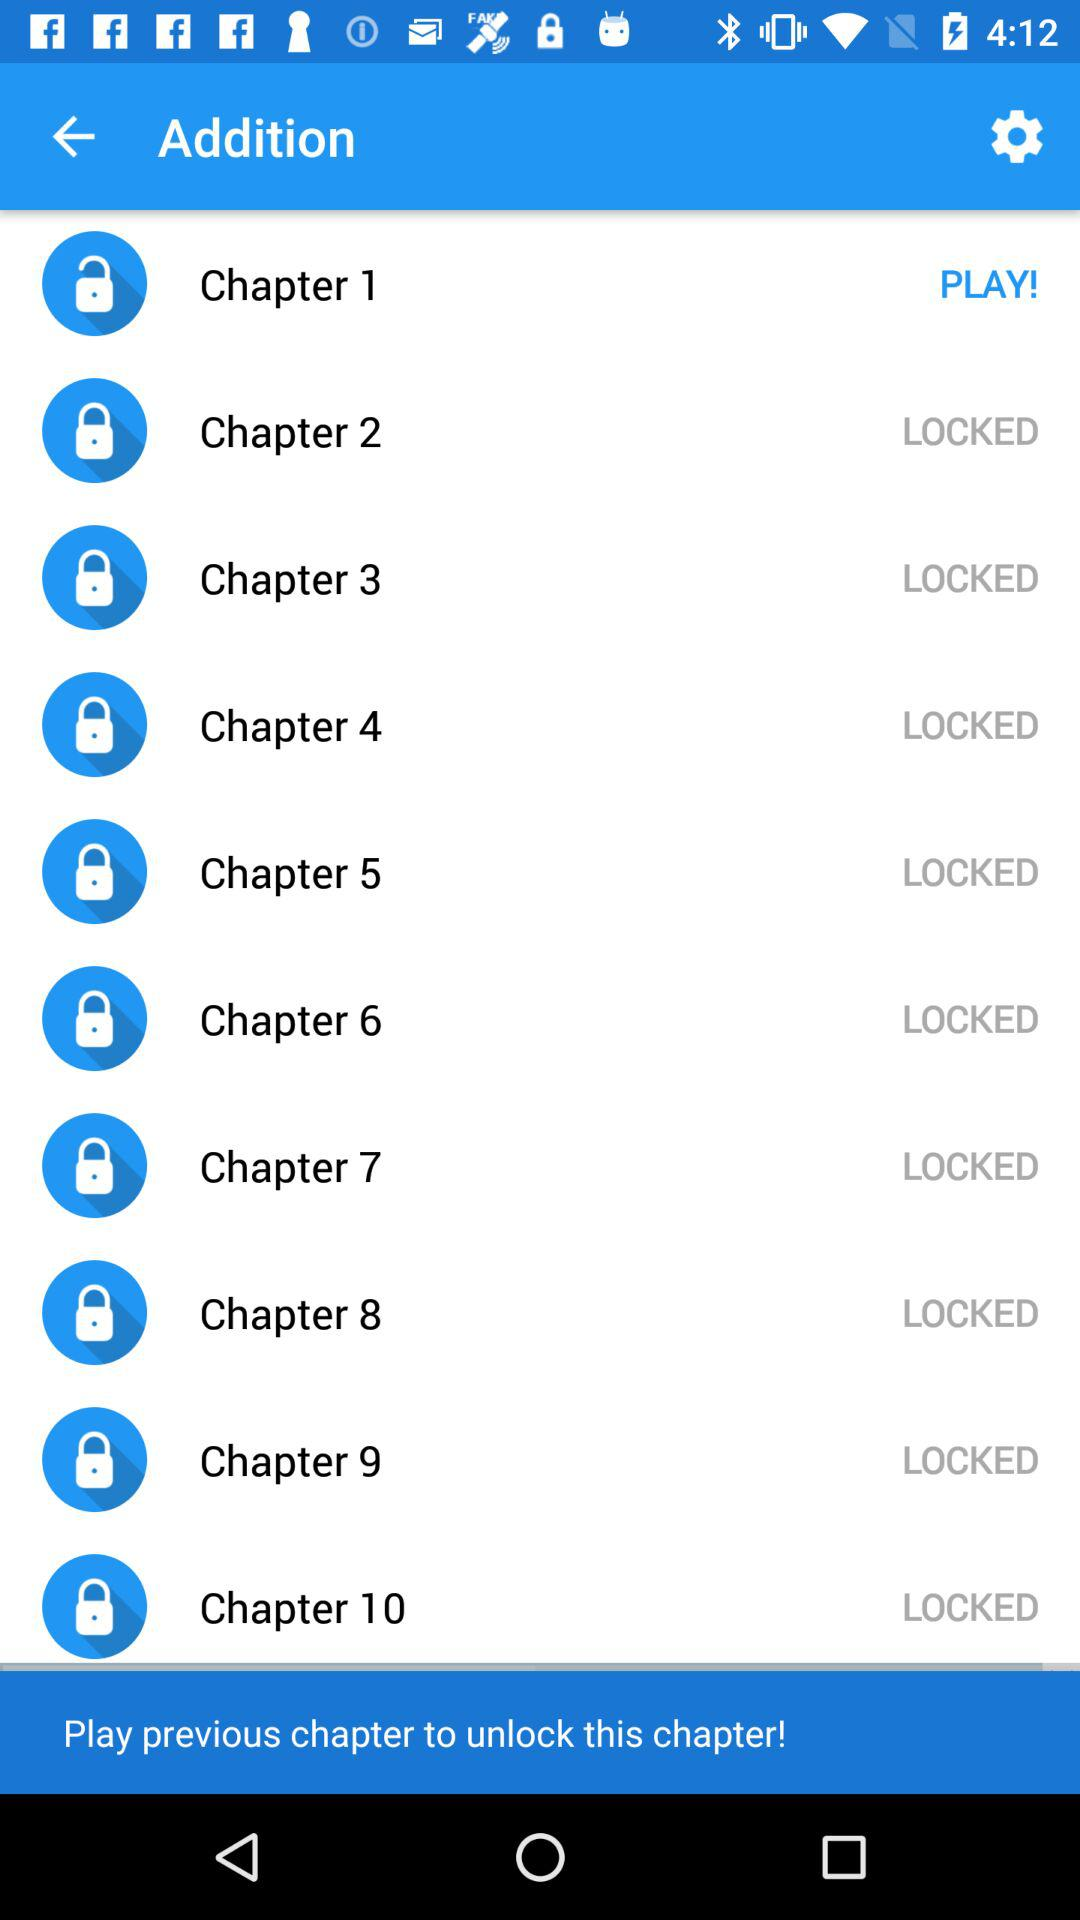What chapter is unlocked? The chapter unlocked is "Chapter 1". 